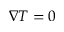<formula> <loc_0><loc_0><loc_500><loc_500>\nabla T = 0</formula> 